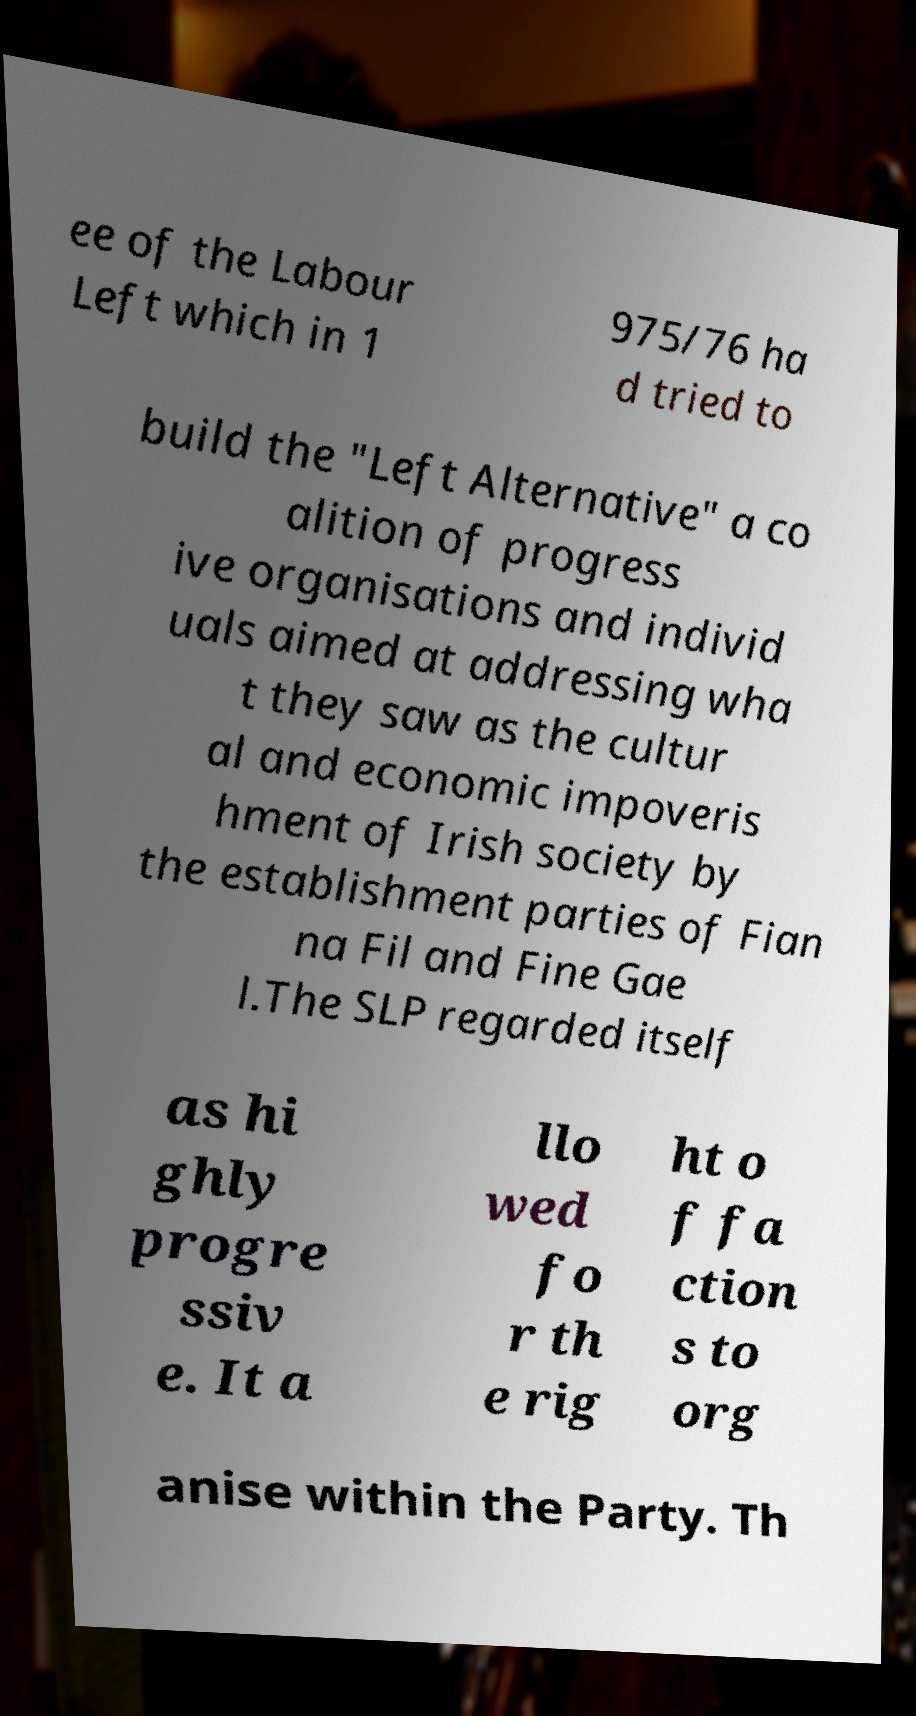Can you read and provide the text displayed in the image?This photo seems to have some interesting text. Can you extract and type it out for me? ee of the Labour Left which in 1 975/76 ha d tried to build the "Left Alternative" a co alition of progress ive organisations and individ uals aimed at addressing wha t they saw as the cultur al and economic impoveris hment of Irish society by the establishment parties of Fian na Fil and Fine Gae l.The SLP regarded itself as hi ghly progre ssiv e. It a llo wed fo r th e rig ht o f fa ction s to org anise within the Party. Th 